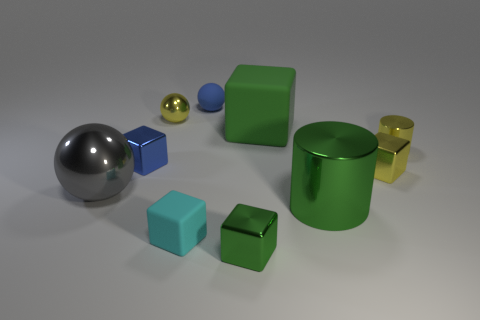Does the small green thing have the same shape as the tiny cyan object?
Your response must be concise. Yes. Are there any other things that have the same color as the small metallic cylinder?
Offer a very short reply. Yes. What shape is the big object that is on the right side of the blue cube and in front of the big green rubber block?
Give a very brief answer. Cylinder. Is the number of small blue spheres that are left of the yellow metal cube the same as the number of shiny cylinders in front of the small cyan block?
Your response must be concise. No. What number of cylinders are either blue metal objects or big gray metallic things?
Your response must be concise. 0. What number of red things are the same material as the big green cylinder?
Offer a terse response. 0. What is the shape of the big rubber object that is the same color as the big cylinder?
Provide a succinct answer. Cube. What is the material of the block that is both in front of the gray shiny sphere and on the right side of the cyan thing?
Your answer should be compact. Metal. The tiny object behind the tiny metallic ball has what shape?
Keep it short and to the point. Sphere. What shape is the large object in front of the sphere that is in front of the green matte cube?
Provide a succinct answer. Cylinder. 